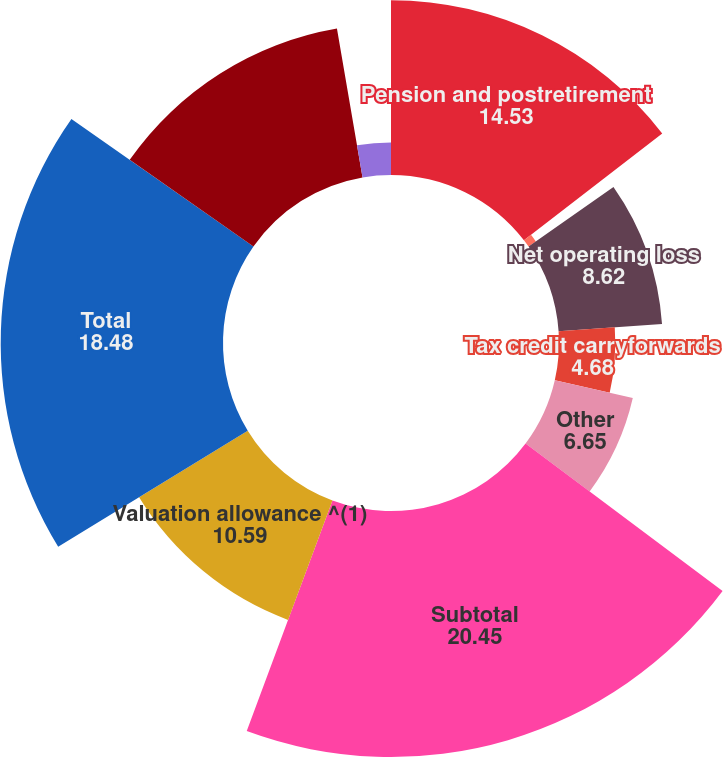Convert chart. <chart><loc_0><loc_0><loc_500><loc_500><pie_chart><fcel>Pension and postretirement<fcel>Accrued expenses<fcel>Net operating loss<fcel>Tax credit carryforwards<fcel>Other<fcel>Subtotal<fcel>Valuation allowance ^(1)<fcel>Total<fcel>Depreciation and amortization<fcel>Investments in affiliates<nl><fcel>14.53%<fcel>0.74%<fcel>8.62%<fcel>4.68%<fcel>6.65%<fcel>20.45%<fcel>10.59%<fcel>18.48%<fcel>12.56%<fcel>2.71%<nl></chart> 